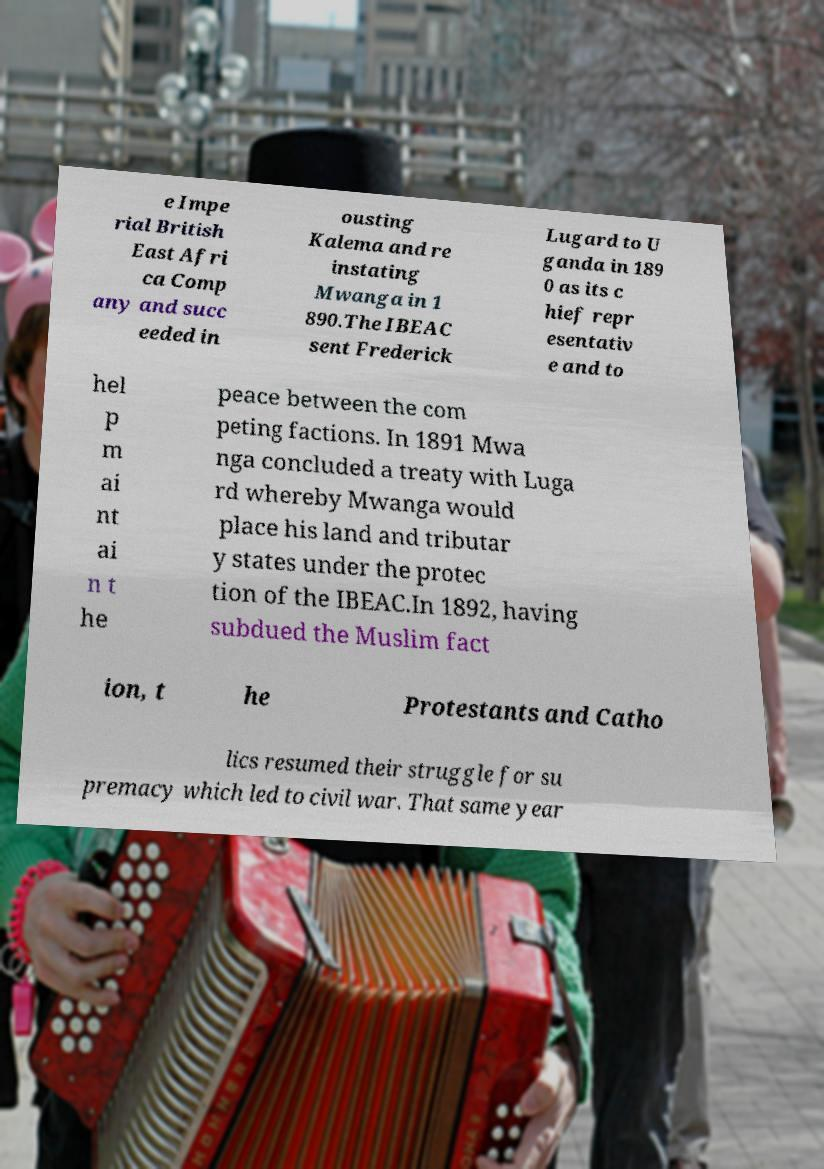Could you extract and type out the text from this image? e Impe rial British East Afri ca Comp any and succ eeded in ousting Kalema and re instating Mwanga in 1 890.The IBEAC sent Frederick Lugard to U ganda in 189 0 as its c hief repr esentativ e and to hel p m ai nt ai n t he peace between the com peting factions. In 1891 Mwa nga concluded a treaty with Luga rd whereby Mwanga would place his land and tributar y states under the protec tion of the IBEAC.In 1892, having subdued the Muslim fact ion, t he Protestants and Catho lics resumed their struggle for su premacy which led to civil war. That same year 